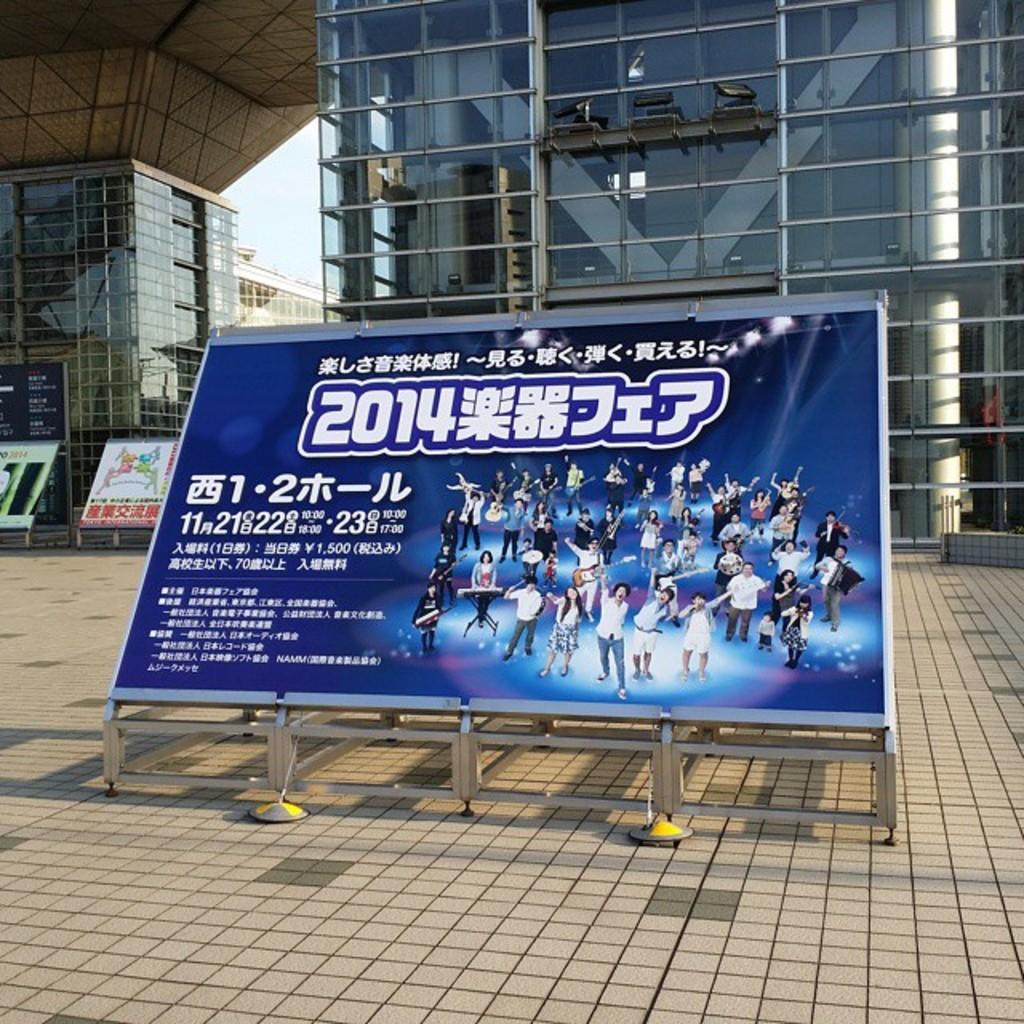<image>
Describe the image concisely. A large billboard for a show in 2014 written in an Asian language sits in front of a glass building. 